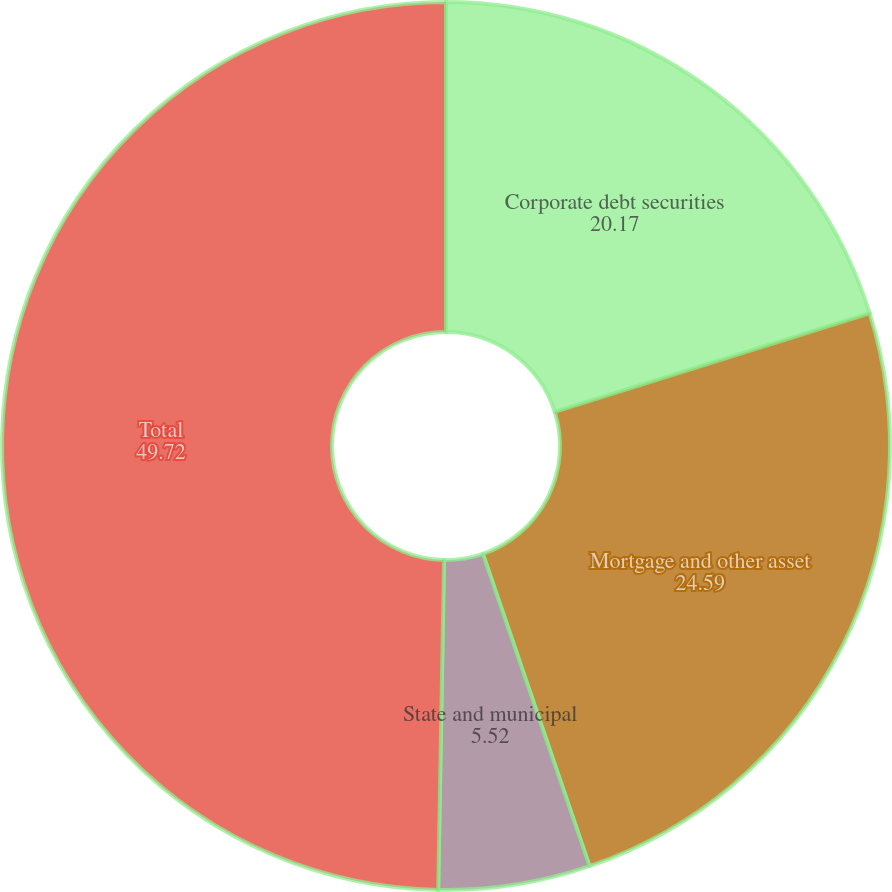<chart> <loc_0><loc_0><loc_500><loc_500><pie_chart><fcel>Corporate debt securities<fcel>Mortgage and other asset<fcel>State and municipal<fcel>Total<nl><fcel>20.17%<fcel>24.59%<fcel>5.52%<fcel>49.72%<nl></chart> 